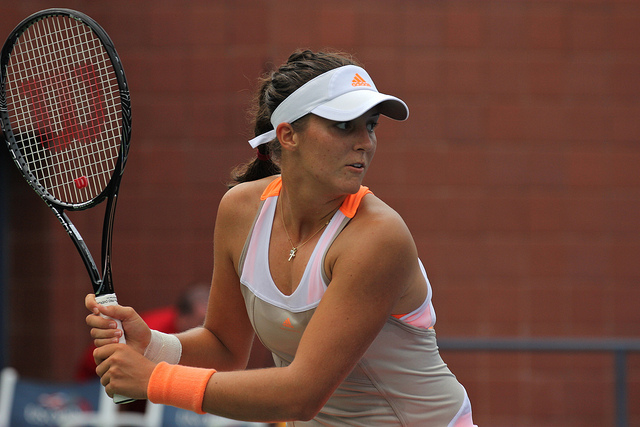<image>Is the player right-handed? I don't know if the player is right-handed. It could be either yes or no. Is the player right-handed? I don't know if the player is right-handed. It can be both right-handed or not. 